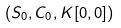Convert formula to latex. <formula><loc_0><loc_0><loc_500><loc_500>( S _ { 0 } , C _ { 0 } , K [ 0 , 0 ] )</formula> 